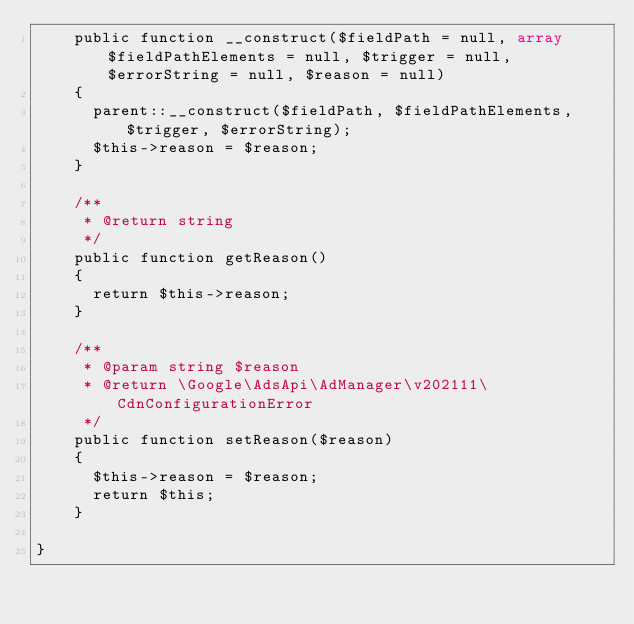<code> <loc_0><loc_0><loc_500><loc_500><_PHP_>    public function __construct($fieldPath = null, array $fieldPathElements = null, $trigger = null, $errorString = null, $reason = null)
    {
      parent::__construct($fieldPath, $fieldPathElements, $trigger, $errorString);
      $this->reason = $reason;
    }

    /**
     * @return string
     */
    public function getReason()
    {
      return $this->reason;
    }

    /**
     * @param string $reason
     * @return \Google\AdsApi\AdManager\v202111\CdnConfigurationError
     */
    public function setReason($reason)
    {
      $this->reason = $reason;
      return $this;
    }

}
</code> 